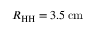<formula> <loc_0><loc_0><loc_500><loc_500>R _ { H H } = 3 . 5 \, { c m }</formula> 